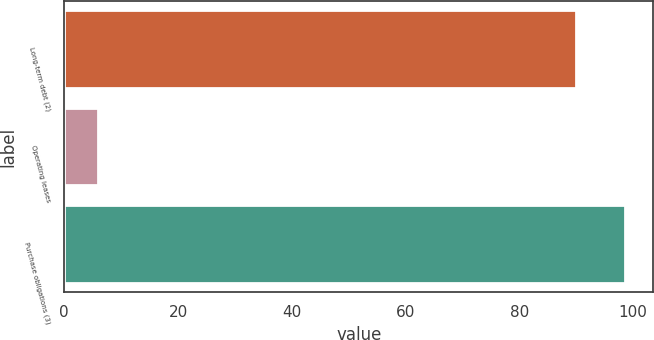<chart> <loc_0><loc_0><loc_500><loc_500><bar_chart><fcel>Long-term debt (2)<fcel>Operating leases<fcel>Purchase obligations (3)<nl><fcel>90<fcel>6<fcel>98.6<nl></chart> 